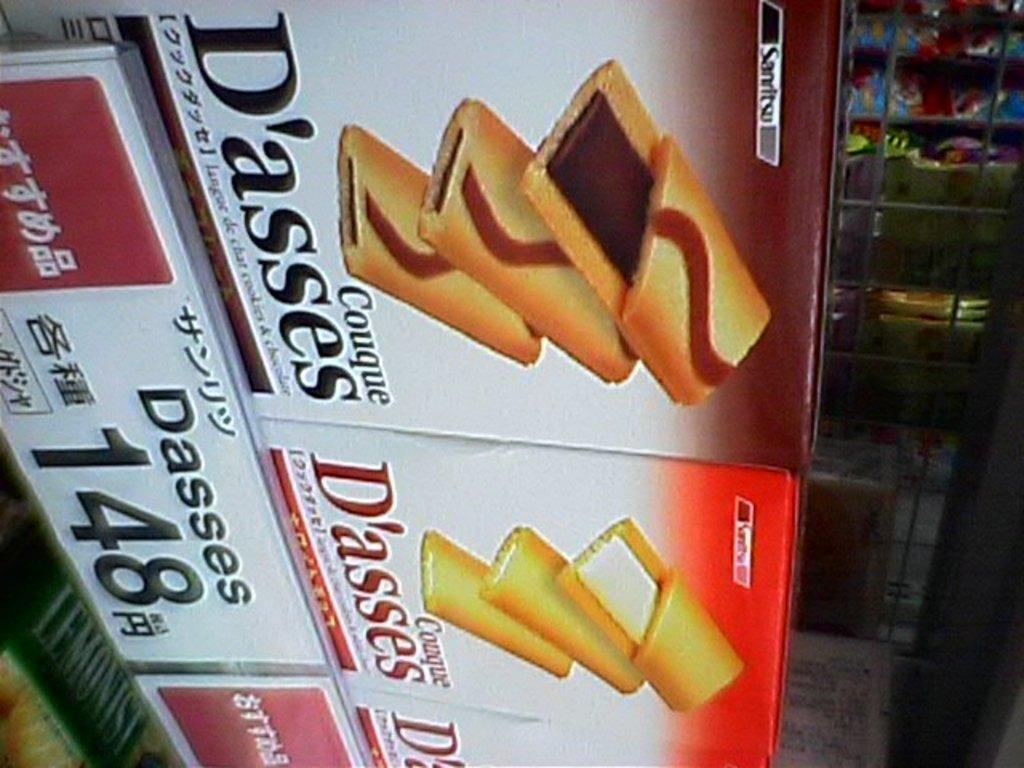What is featured on the posters in the image? The posters contain images of food items. Are there any words on the posters? Yes, there is text on the posters. What can be seen in the background of the image? There are objects visible in the background of the image. Can you tell me how many hens are depicted on the posters? There are no hens depicted on the posters; they contain images of food items. What type of appliance is visible in the background of the image? There is no appliance visible in the background of the image. 